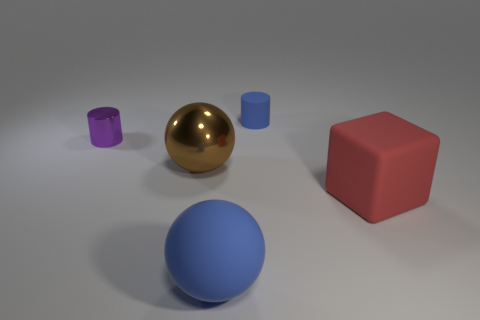What color is the matte thing that is the same shape as the small shiny object?
Give a very brief answer. Blue. Do the red thing and the blue rubber cylinder have the same size?
Keep it short and to the point. No. Is the number of blocks that are left of the large metal ball the same as the number of yellow metal spheres?
Your response must be concise. Yes. Are there any objects in front of the ball that is in front of the large brown metallic object?
Your response must be concise. No. What size is the blue rubber object that is in front of the big rubber object that is on the right side of the cylinder that is on the right side of the large rubber sphere?
Your answer should be compact. Large. What material is the small cylinder right of the matte object that is to the left of the blue matte cylinder made of?
Your answer should be very brief. Rubber. Is there a tiny blue thing of the same shape as the tiny purple metal thing?
Offer a very short reply. Yes. What is the shape of the tiny blue rubber thing?
Your answer should be compact. Cylinder. What material is the blue object that is in front of the large matte thing that is right of the tiny cylinder right of the large blue rubber ball made of?
Your answer should be very brief. Rubber. Is the number of small purple metallic objects that are right of the tiny purple object greater than the number of tiny brown cubes?
Your answer should be compact. No. 